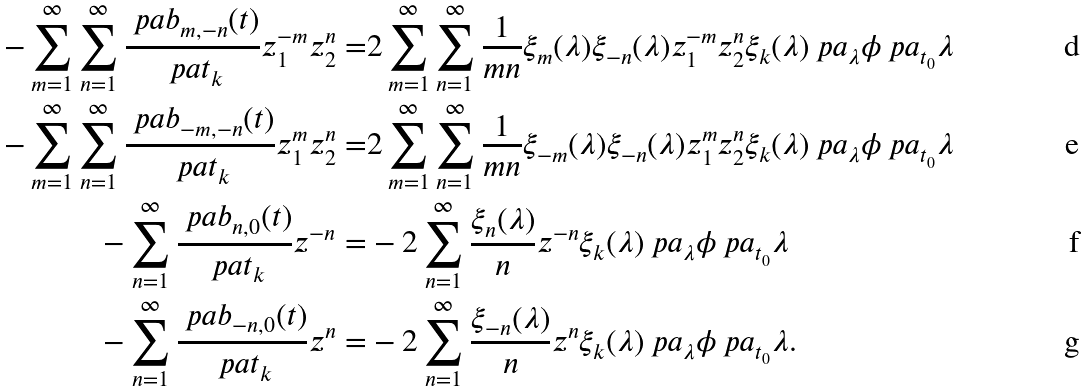<formula> <loc_0><loc_0><loc_500><loc_500>- \sum _ { m = 1 } ^ { \infty } \sum _ { n = 1 } ^ { \infty } \frac { \ p a b _ { m , - n } ( t ) } { \ p a t _ { k } } z _ { 1 } ^ { - m } z _ { 2 } ^ { n } = & 2 \sum _ { m = 1 } ^ { \infty } \sum _ { n = 1 } ^ { \infty } \frac { 1 } { m n } \xi _ { m } ( \lambda ) \xi _ { - n } ( \lambda ) z _ { 1 } ^ { - m } z _ { 2 } ^ { n } \xi _ { k } ( \lambda ) \ p a _ { \lambda } \phi \ p a _ { t _ { 0 } } \lambda \\ - \sum _ { m = 1 } ^ { \infty } \sum _ { n = 1 } ^ { \infty } \frac { \ p a b _ { - m , - n } ( t ) } { \ p a t _ { k } } z _ { 1 } ^ { m } z _ { 2 } ^ { n } = & 2 \sum _ { m = 1 } ^ { \infty } \sum _ { n = 1 } ^ { \infty } \frac { 1 } { m n } \xi _ { - m } ( \lambda ) \xi _ { - n } ( \lambda ) z _ { 1 } ^ { m } z _ { 2 } ^ { n } \xi _ { k } ( \lambda ) \ p a _ { \lambda } \phi \ p a _ { t _ { 0 } } \lambda \\ - \sum _ { n = 1 } ^ { \infty } \frac { \ p a b _ { n , 0 } ( t ) } { \ p a t _ { k } } z ^ { - n } = & - 2 \sum _ { n = 1 } ^ { \infty } \frac { \xi _ { n } ( \lambda ) } { n } z ^ { - n } \xi _ { k } ( \lambda ) \ p a _ { \lambda } \phi \ p a _ { t _ { 0 } } \lambda \\ - \sum _ { n = 1 } ^ { \infty } \frac { \ p a b _ { - n , 0 } ( t ) } { \ p a t _ { k } } z ^ { n } = & - 2 \sum _ { n = 1 } ^ { \infty } \frac { \xi _ { - n } ( \lambda ) } { n } z ^ { n } \xi _ { k } ( \lambda ) \ p a _ { \lambda } \phi \ p a _ { t _ { 0 } } \lambda .</formula> 